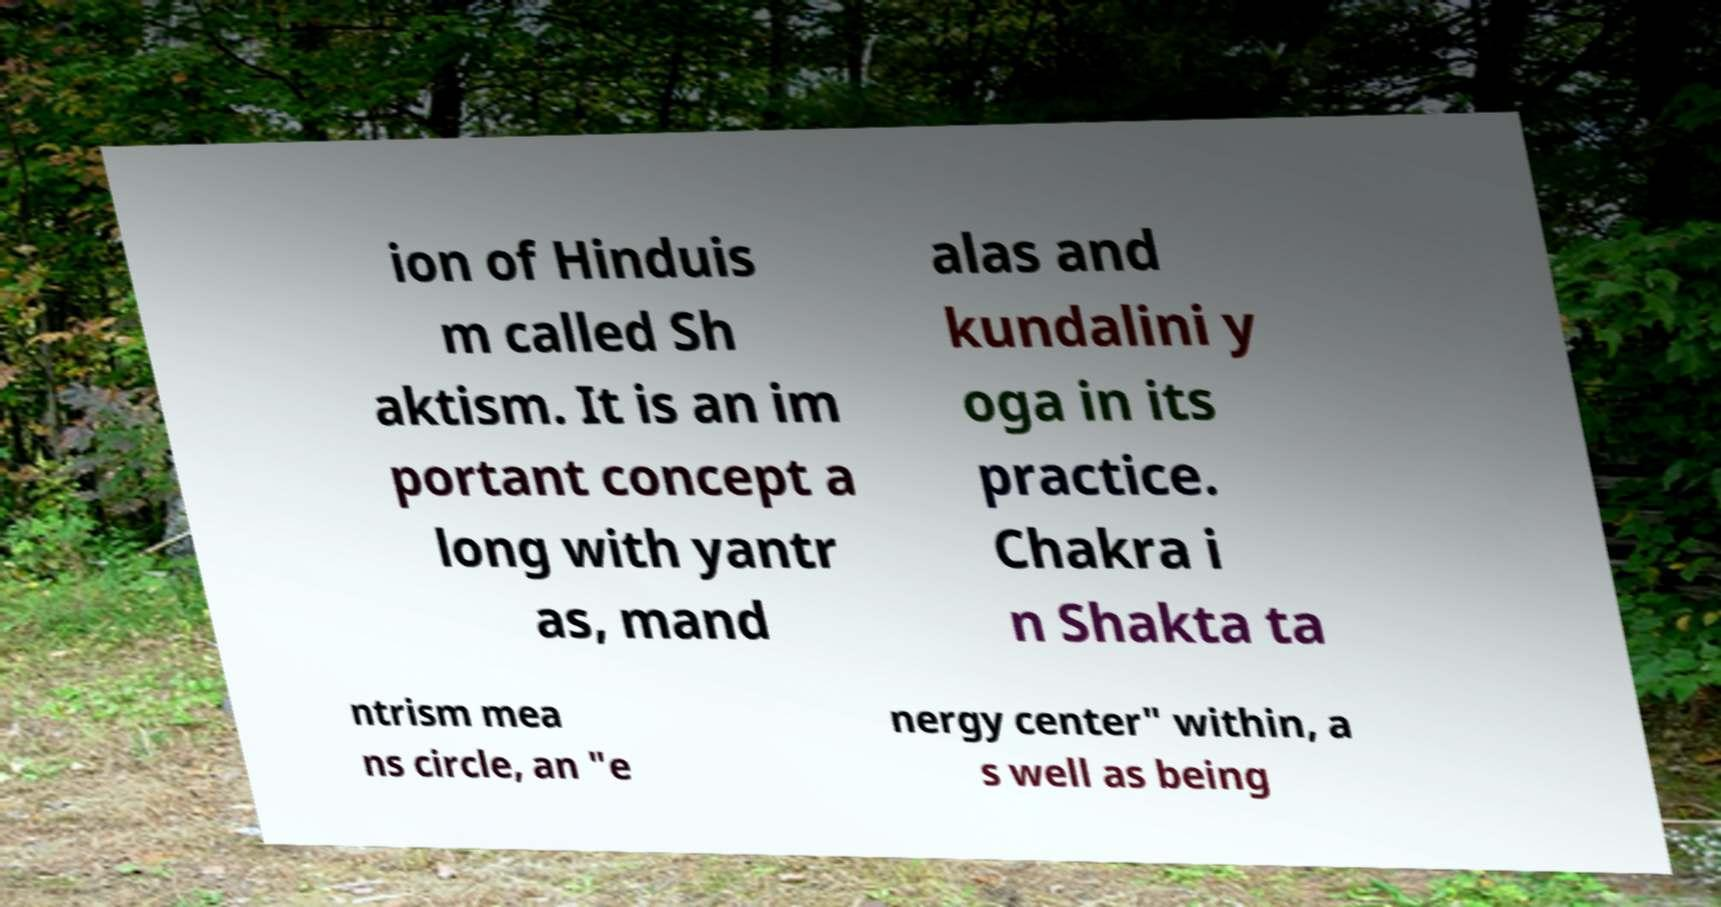I need the written content from this picture converted into text. Can you do that? ion of Hinduis m called Sh aktism. It is an im portant concept a long with yantr as, mand alas and kundalini y oga in its practice. Chakra i n Shakta ta ntrism mea ns circle, an "e nergy center" within, a s well as being 